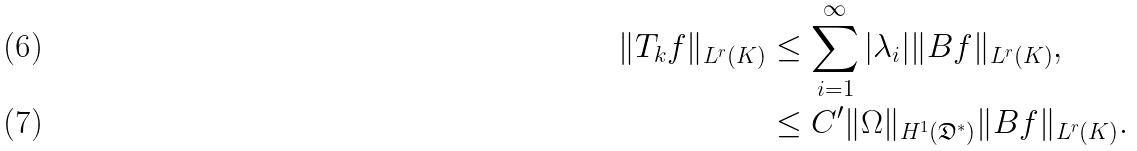<formula> <loc_0><loc_0><loc_500><loc_500>\| T _ { k } f \| _ { L ^ { r } ( K ) } & \leq \sum _ { i = 1 } ^ { \infty } | \lambda _ { i } | \| B f \| _ { L ^ { r } ( K ) } , \\ & \leq C ^ { \prime } \| \Omega \| _ { H ^ { 1 } ( \mathfrak { D } ^ { * } ) } \| B f \| _ { L ^ { r } ( K ) } .</formula> 